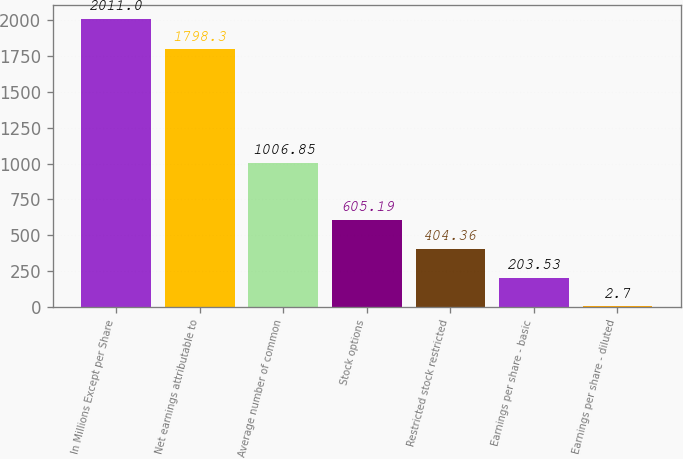<chart> <loc_0><loc_0><loc_500><loc_500><bar_chart><fcel>In Millions Except per Share<fcel>Net earnings attributable to<fcel>Average number of common<fcel>Stock options<fcel>Restricted stock restricted<fcel>Earnings per share - basic<fcel>Earnings per share - diluted<nl><fcel>2011<fcel>1798.3<fcel>1006.85<fcel>605.19<fcel>404.36<fcel>203.53<fcel>2.7<nl></chart> 